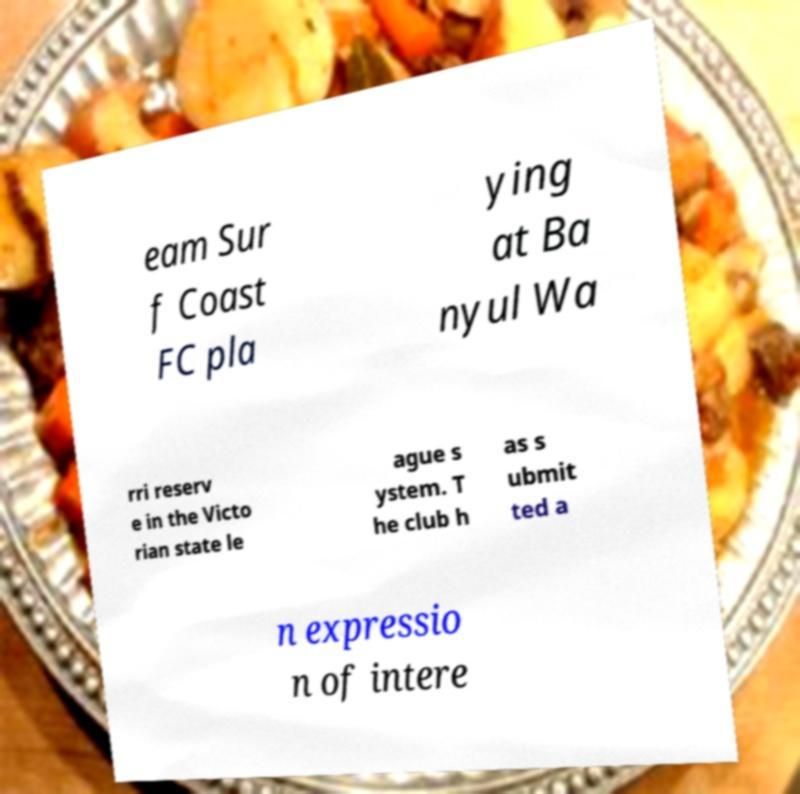I need the written content from this picture converted into text. Can you do that? eam Sur f Coast FC pla ying at Ba nyul Wa rri reserv e in the Victo rian state le ague s ystem. T he club h as s ubmit ted a n expressio n of intere 